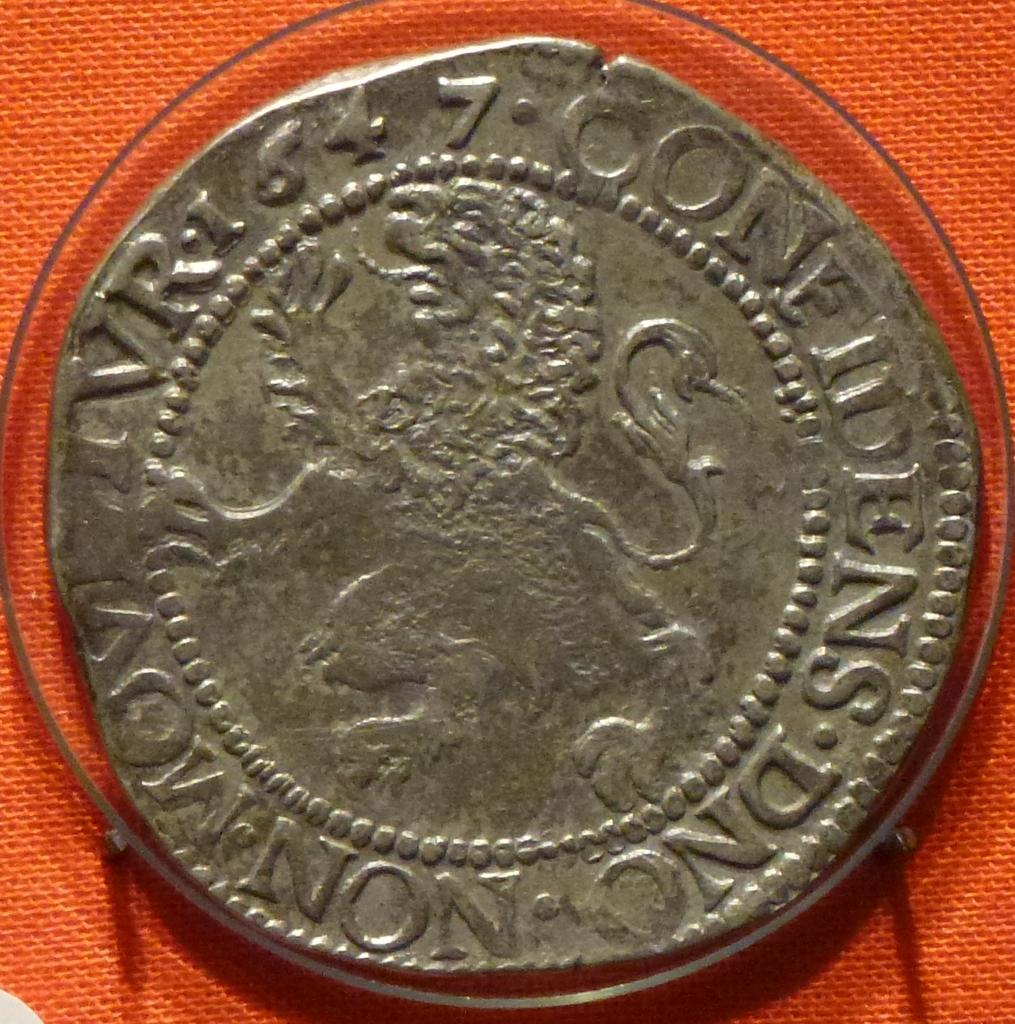<image>
Provide a brief description of the given image. An old coin from 1647 has a lion on the front. 